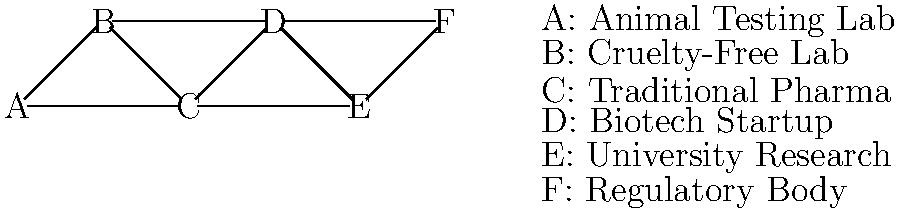In the node-link diagram representing research collaborations in pharmaceutical studies, which entity has the highest degree centrality, and what implications does this have for the flow of information and resources in the network? To answer this question, we need to follow these steps:

1. Understand degree centrality:
   Degree centrality is the number of direct connections a node has to other nodes in the network.

2. Count the connections for each node:
   A: 2 connections
   B: 3 connections
   C: 4 connections
   D: 4 connections
   E: 3 connections
   F: 2 connections

3. Identify the node(s) with the highest degree centrality:
   Nodes C (Traditional Pharma) and D (Biotech Startup) both have the highest degree centrality with 4 connections each.

4. Analyze the implications:
   a) Information flow: Nodes C and D are in the best position to receive and distribute information quickly across the network.
   b) Resource access: These nodes have the most diverse set of collaborators, potentially accessing a wide range of resources and expertise.
   c) Influence: C and D are likely to have significant influence over research directions and methodologies.
   d) Bridge between methodologies: C (Traditional Pharma) connects both animal testing (A) and cruelty-free (B) labs, suggesting a pivotal role in comparing and integrating different research approaches.
   e) Innovation potential: D (Biotech Startup) links academia (E) with industry (C) and regulatory bodies (F), indicating a possible role in translating research into practical applications.

5. Consider the persona's perspective:
   As a scientist skeptical about cruelty-free alternatives, the central position of Traditional Pharma (C) might be seen as validating the importance of conventional methods, including animal testing, in pharmaceutical research.
Answer: Nodes C (Traditional Pharma) and D (Biotech Startup); they act as key information hubs and resource distributors, bridging different research approaches and stakeholders in pharmaceutical studies. 